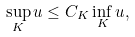Convert formula to latex. <formula><loc_0><loc_0><loc_500><loc_500>\sup _ { K } u \leq C _ { K } \inf _ { K } u ,</formula> 